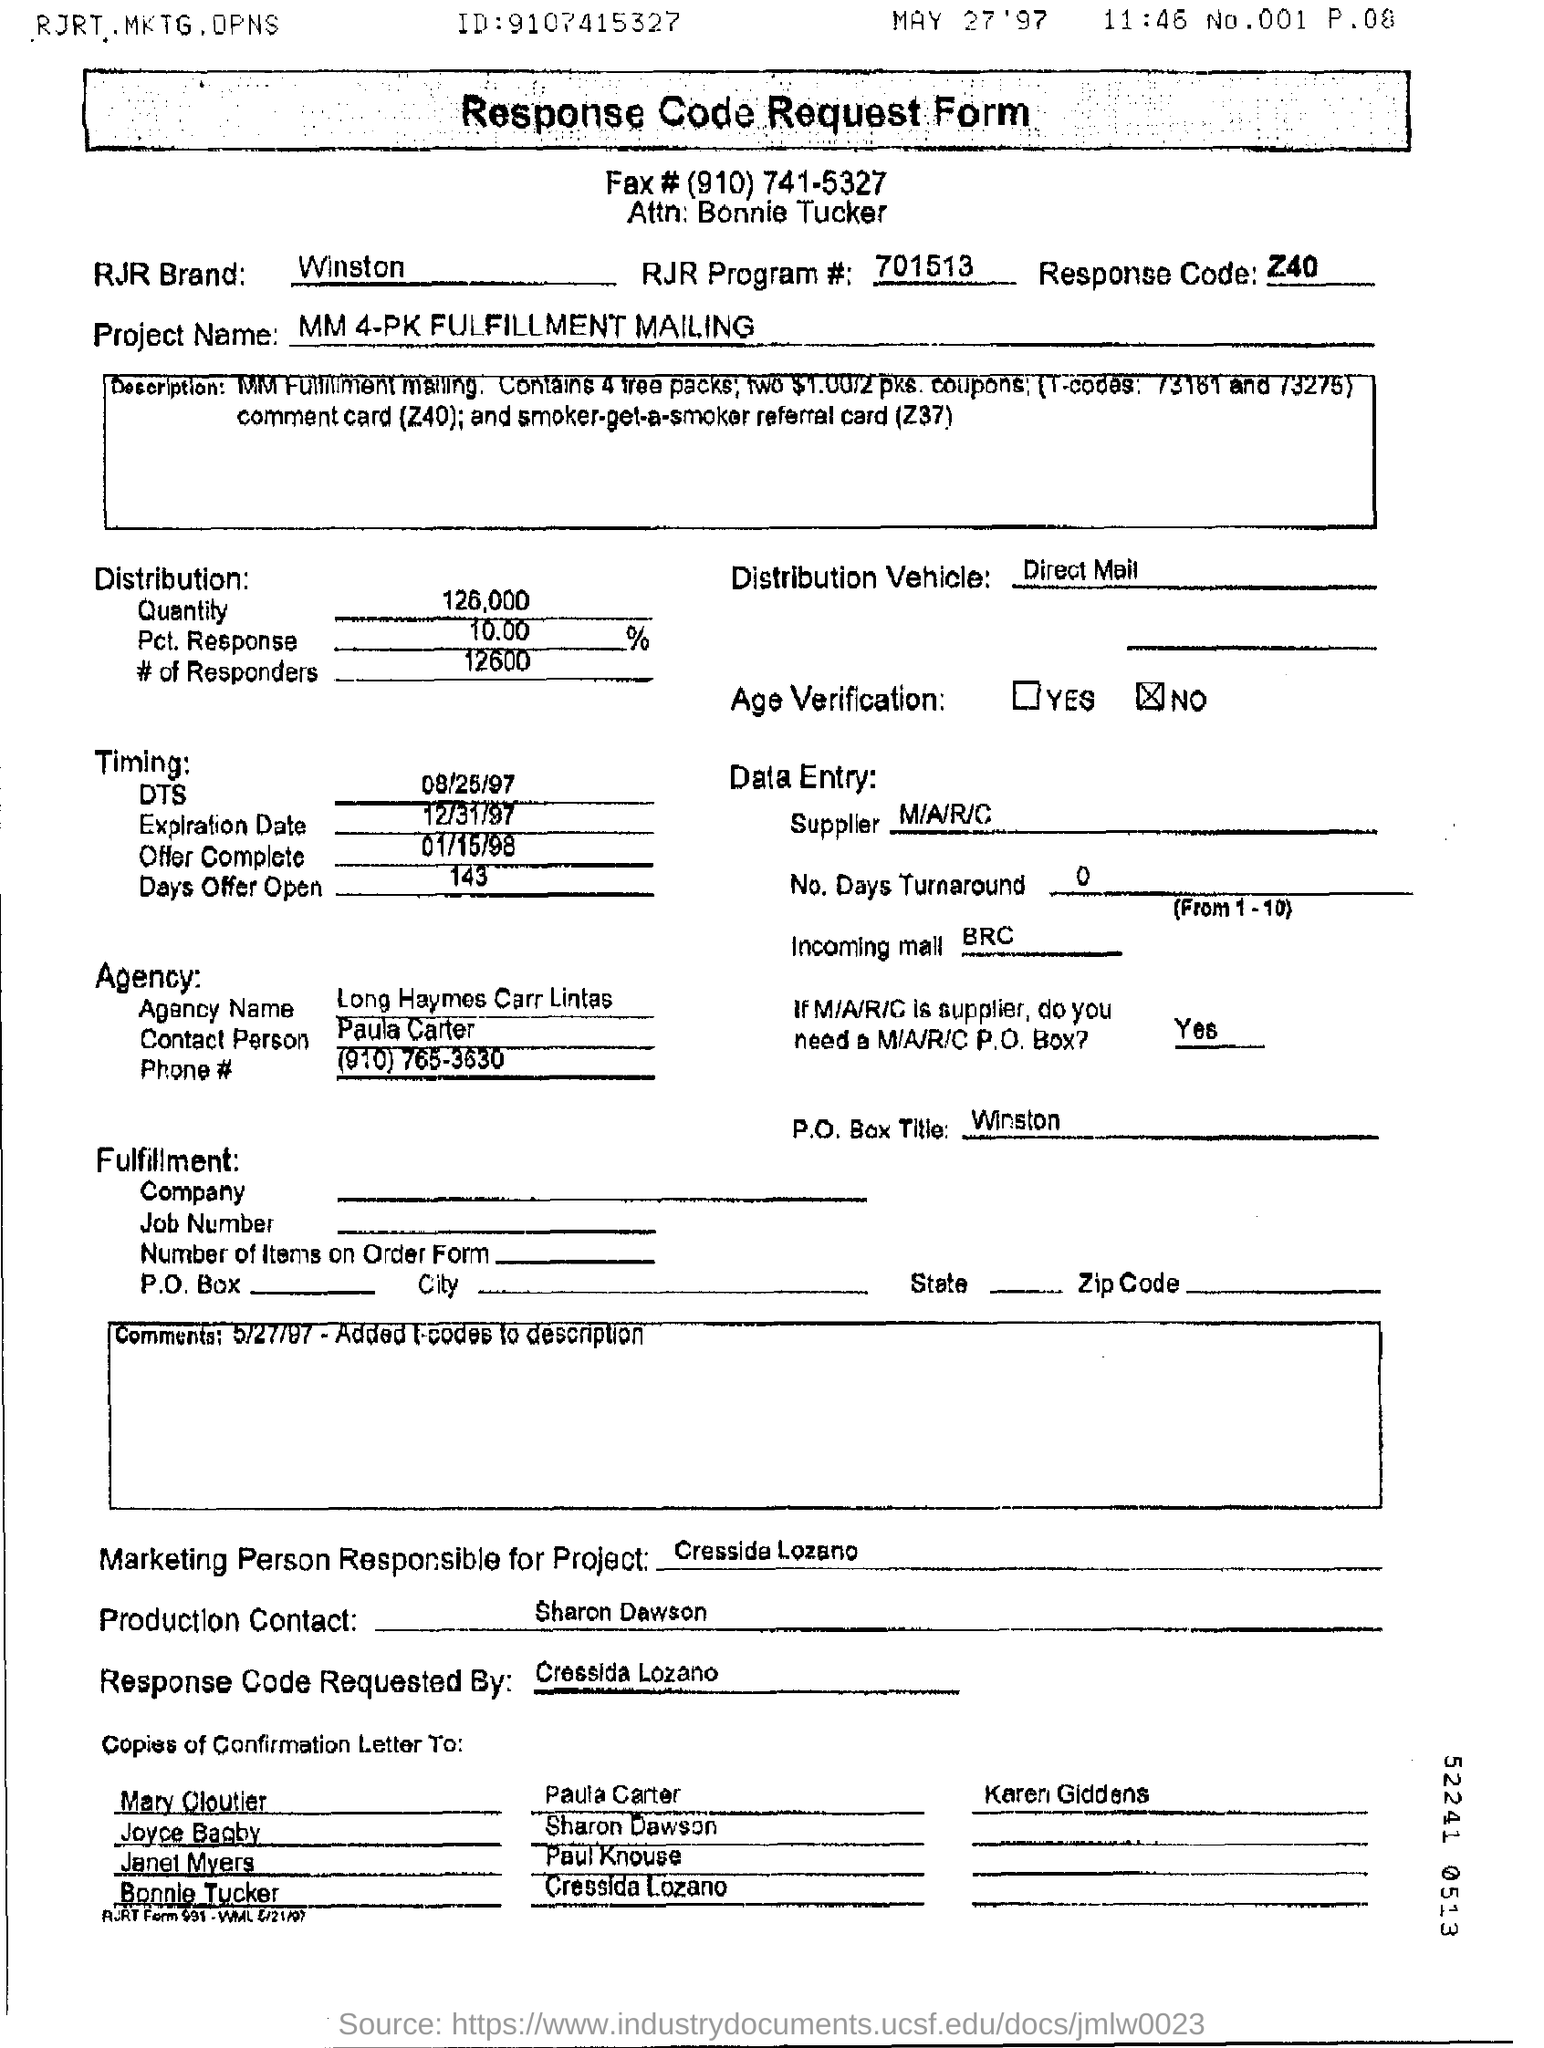What is the response code ?
Your answer should be very brief. Z40. 